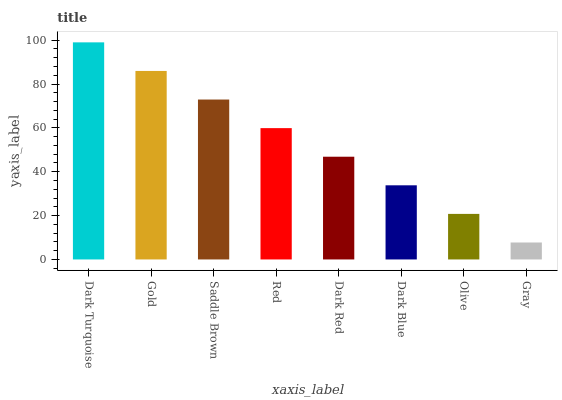Is Gold the minimum?
Answer yes or no. No. Is Gold the maximum?
Answer yes or no. No. Is Dark Turquoise greater than Gold?
Answer yes or no. Yes. Is Gold less than Dark Turquoise?
Answer yes or no. Yes. Is Gold greater than Dark Turquoise?
Answer yes or no. No. Is Dark Turquoise less than Gold?
Answer yes or no. No. Is Red the high median?
Answer yes or no. Yes. Is Dark Red the low median?
Answer yes or no. Yes. Is Dark Turquoise the high median?
Answer yes or no. No. Is Gray the low median?
Answer yes or no. No. 